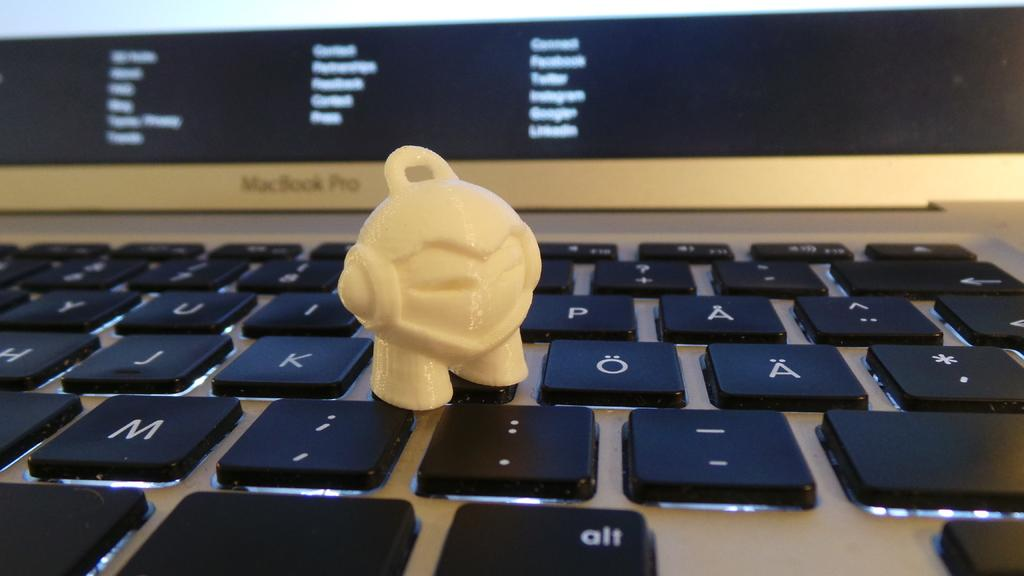<image>
Provide a brief description of the given image. A white object stands next to the letter K on a keyboard. 